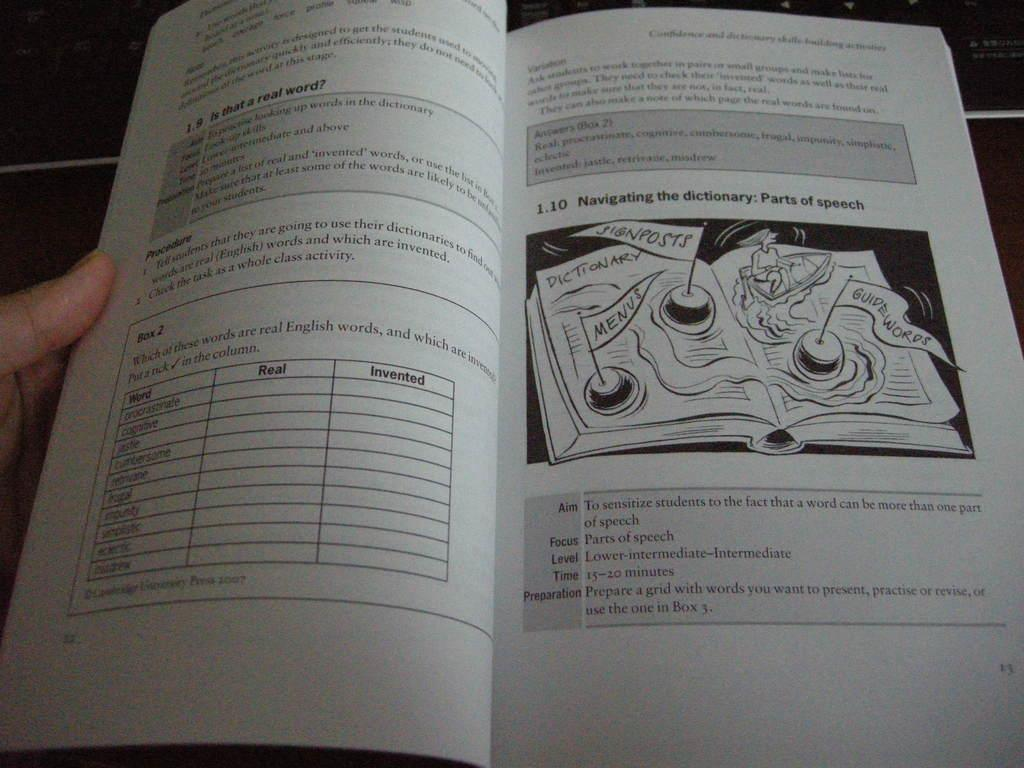Provide a one-sentence caption for the provided image. A person looking at an open book about Parts of speech. 